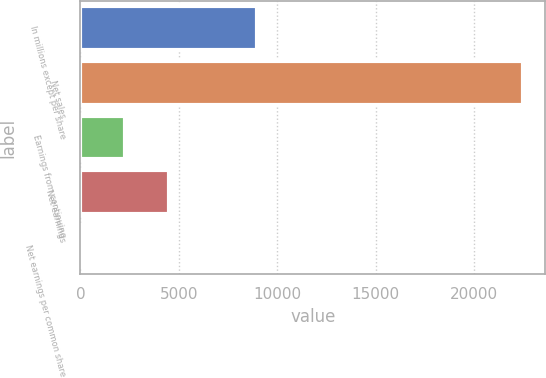Convert chart to OTSL. <chart><loc_0><loc_0><loc_500><loc_500><bar_chart><fcel>In millions except per share<fcel>Net sales<fcel>Earnings from continuing<fcel>Net earnings<fcel>Net earnings per common share<nl><fcel>8993.26<fcel>22479<fcel>2250.38<fcel>4498.01<fcel>2.75<nl></chart> 